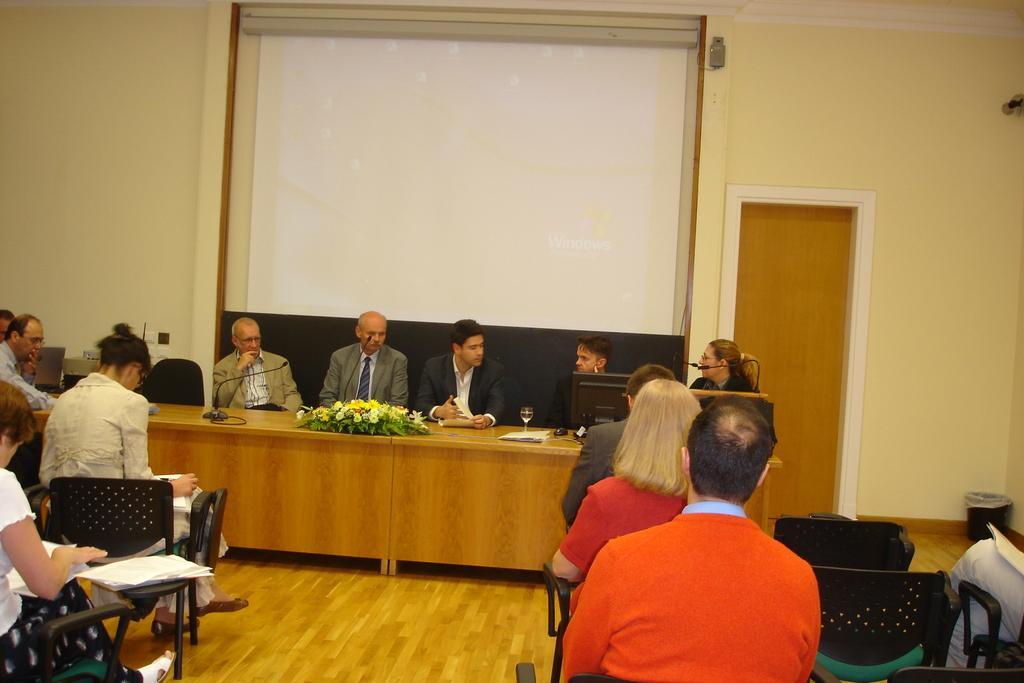In one or two sentences, can you explain what this image depicts? In this image we can see few persons are sitting on the chairs and among them few persons are holding papers in their hands and there are papers on the chair. In the background we can see few persons are sitting on the chairs at the table and on the table there is a glass, monitor, flowers bouquet, mouse, monitor, laptop, microphone and object, screen, door, wall and a dustbin on the floor. 